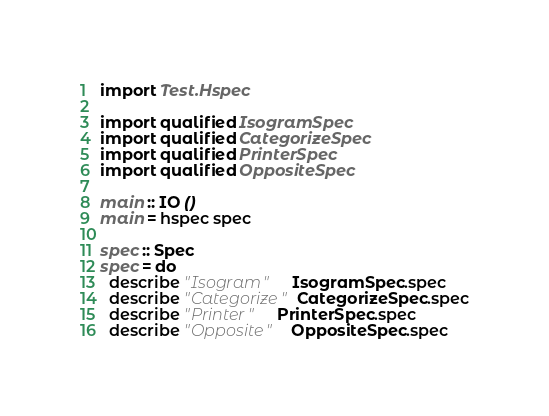<code> <loc_0><loc_0><loc_500><loc_500><_Haskell_>import Test.Hspec

import qualified IsogramSpec
import qualified CategorizeSpec
import qualified PrinterSpec
import qualified OppositeSpec

main :: IO ()
main = hspec spec

spec :: Spec
spec = do
  describe "Isogram"     IsogramSpec.spec
  describe "Categorize"  CategorizeSpec.spec
  describe "Printer"     PrinterSpec.spec
  describe "Opposite"    OppositeSpec.spec
</code> 